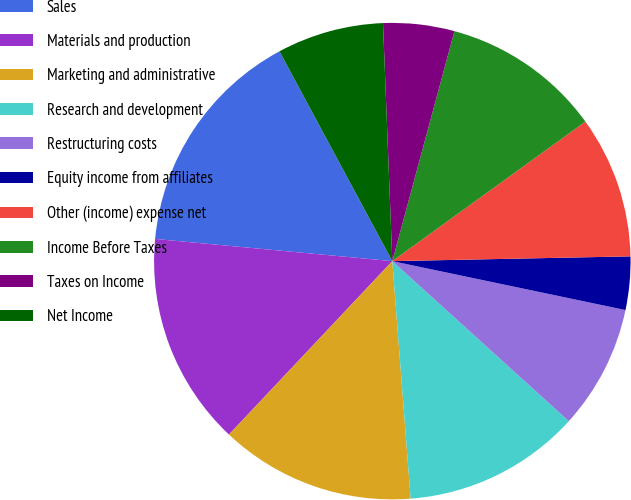Convert chart. <chart><loc_0><loc_0><loc_500><loc_500><pie_chart><fcel>Sales<fcel>Materials and production<fcel>Marketing and administrative<fcel>Research and development<fcel>Restructuring costs<fcel>Equity income from affiliates<fcel>Other (income) expense net<fcel>Income Before Taxes<fcel>Taxes on Income<fcel>Net Income<nl><fcel>15.66%<fcel>14.46%<fcel>13.25%<fcel>12.05%<fcel>8.43%<fcel>3.61%<fcel>9.64%<fcel>10.84%<fcel>4.82%<fcel>7.23%<nl></chart> 